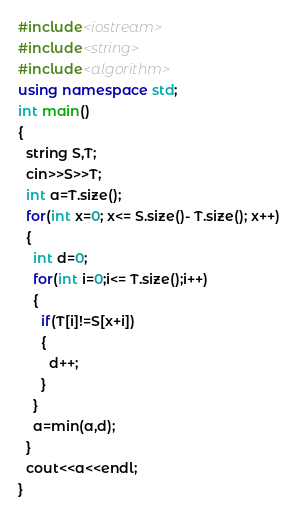Convert code to text. <code><loc_0><loc_0><loc_500><loc_500><_C++_>#include<iostream>
#include<string>
#include<algorithm>
using namespace std;
int main()
{
  string S,T;
  cin>>S>>T;
  int a=T.size();
  for(int x=0; x<= S.size()- T.size(); x++)
  { 
    int d=0;
    for(int i=0;i<= T.size();i++)
    {
      if(T[i]!=S[x+i])
      {
        d++;
      }
    }
    a=min(a,d);
  }
  cout<<a<<endl;
}
</code> 